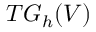Convert formula to latex. <formula><loc_0><loc_0><loc_500><loc_500>T G _ { h } ( V )</formula> 